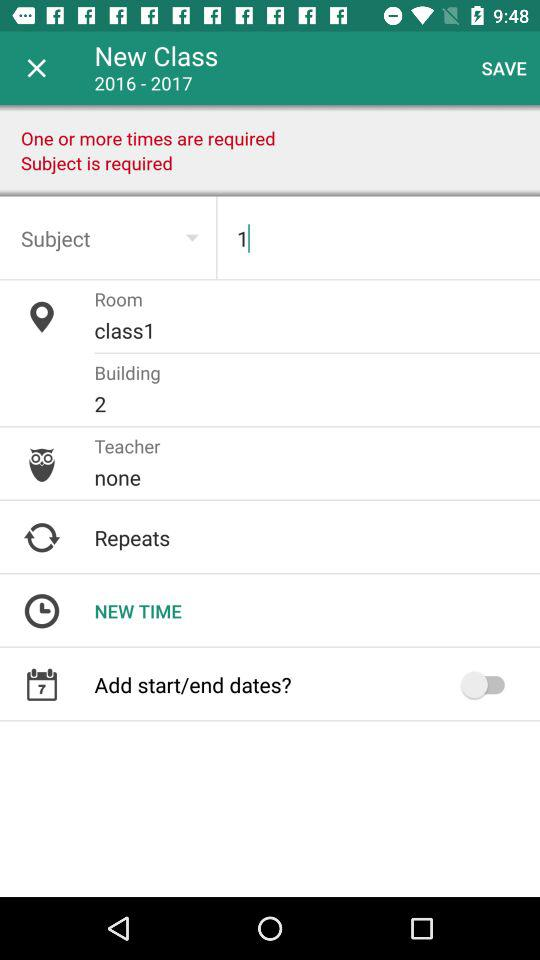What's the status of "Add start/end dates?"? The status is "off". 